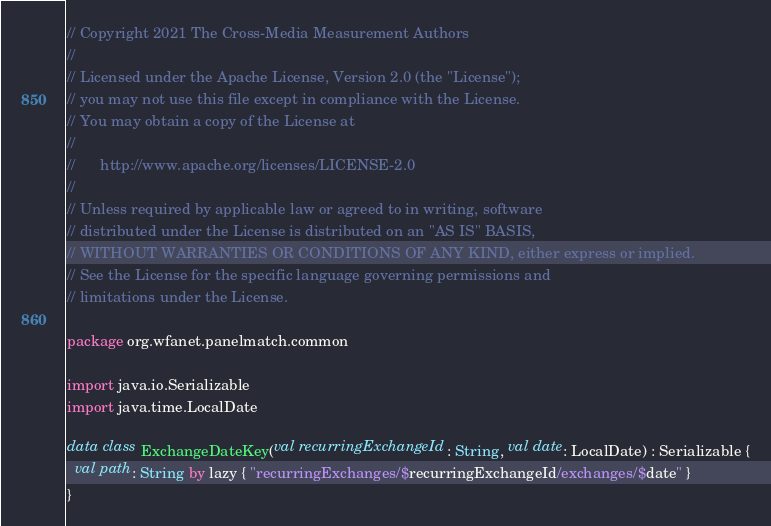Convert code to text. <code><loc_0><loc_0><loc_500><loc_500><_Kotlin_>// Copyright 2021 The Cross-Media Measurement Authors
//
// Licensed under the Apache License, Version 2.0 (the "License");
// you may not use this file except in compliance with the License.
// You may obtain a copy of the License at
//
//      http://www.apache.org/licenses/LICENSE-2.0
//
// Unless required by applicable law or agreed to in writing, software
// distributed under the License is distributed on an "AS IS" BASIS,
// WITHOUT WARRANTIES OR CONDITIONS OF ANY KIND, either express or implied.
// See the License for the specific language governing permissions and
// limitations under the License.

package org.wfanet.panelmatch.common

import java.io.Serializable
import java.time.LocalDate

data class ExchangeDateKey(val recurringExchangeId: String, val date: LocalDate) : Serializable {
  val path: String by lazy { "recurringExchanges/$recurringExchangeId/exchanges/$date" }
}
</code> 